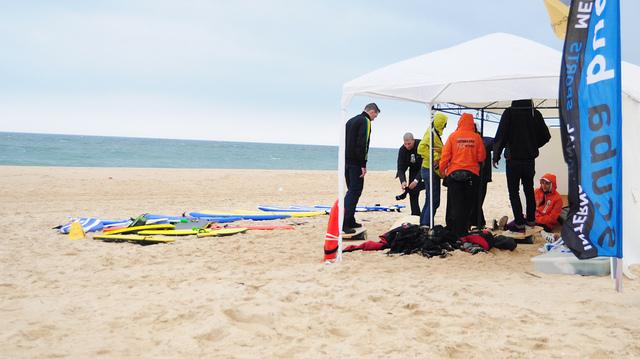What are they doing under the canopy?

Choices:
A) fighting
B) resting
C) changing clothes
D) eating changing clothes 